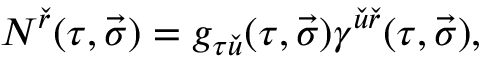Convert formula to latex. <formula><loc_0><loc_0><loc_500><loc_500>N ^ { \check { r } } ( \tau , \vec { \sigma } ) = g _ { \tau \check { u } } ( \tau , \vec { \sigma } ) \gamma ^ { \check { u } \check { r } } ( \tau , \vec { \sigma } ) ,</formula> 